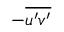Convert formula to latex. <formula><loc_0><loc_0><loc_500><loc_500>- \overline { { u ^ { \prime } v ^ { \prime } } }</formula> 